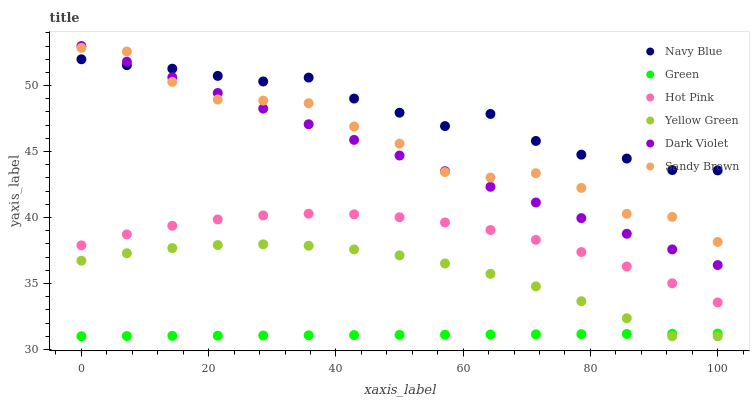Does Green have the minimum area under the curve?
Answer yes or no. Yes. Does Navy Blue have the maximum area under the curve?
Answer yes or no. Yes. Does Hot Pink have the minimum area under the curve?
Answer yes or no. No. Does Hot Pink have the maximum area under the curve?
Answer yes or no. No. Is Green the smoothest?
Answer yes or no. Yes. Is Sandy Brown the roughest?
Answer yes or no. Yes. Is Navy Blue the smoothest?
Answer yes or no. No. Is Navy Blue the roughest?
Answer yes or no. No. Does Yellow Green have the lowest value?
Answer yes or no. Yes. Does Hot Pink have the lowest value?
Answer yes or no. No. Does Dark Violet have the highest value?
Answer yes or no. Yes. Does Navy Blue have the highest value?
Answer yes or no. No. Is Yellow Green less than Hot Pink?
Answer yes or no. Yes. Is Dark Violet greater than Green?
Answer yes or no. Yes. Does Navy Blue intersect Dark Violet?
Answer yes or no. Yes. Is Navy Blue less than Dark Violet?
Answer yes or no. No. Is Navy Blue greater than Dark Violet?
Answer yes or no. No. Does Yellow Green intersect Hot Pink?
Answer yes or no. No. 